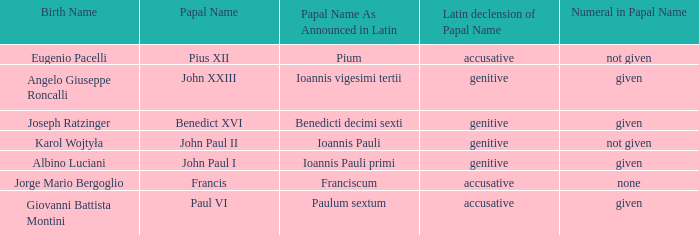For Pope Paul VI, what is the declension of his papal name? Accusative. 